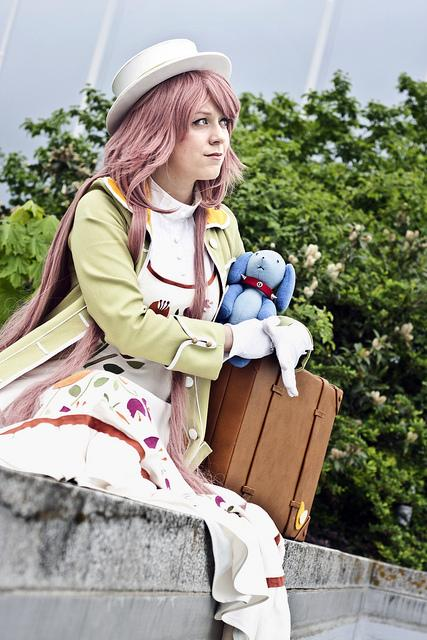What is next to the girl? Please explain your reasoning. luggage. The girl sitting on the wall has luggage next to her such as a brown suitcase. 